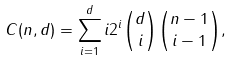<formula> <loc_0><loc_0><loc_500><loc_500>C ( n , d ) = \sum _ { i = 1 } ^ { d } i 2 ^ { i } \binom { d } { i } \binom { n - 1 } { i - 1 } ,</formula> 